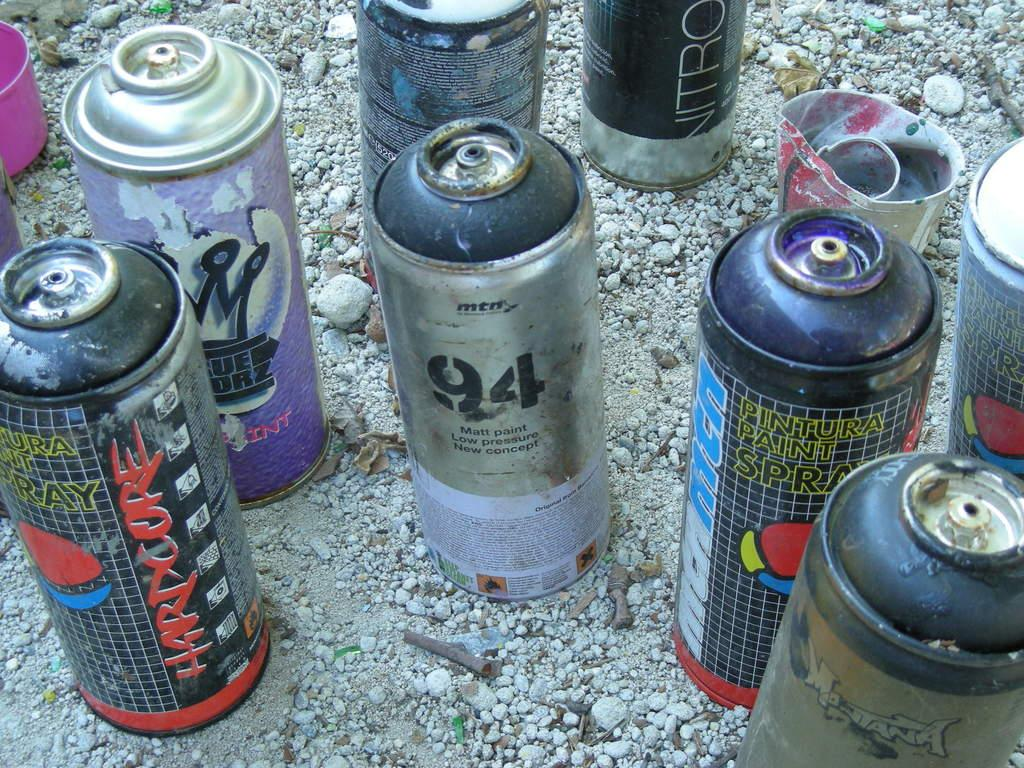<image>
Provide a brief description of the given image. Different kinds of old spray paint cans sit in the gravel. The word Hardcore is written across the side of one. 